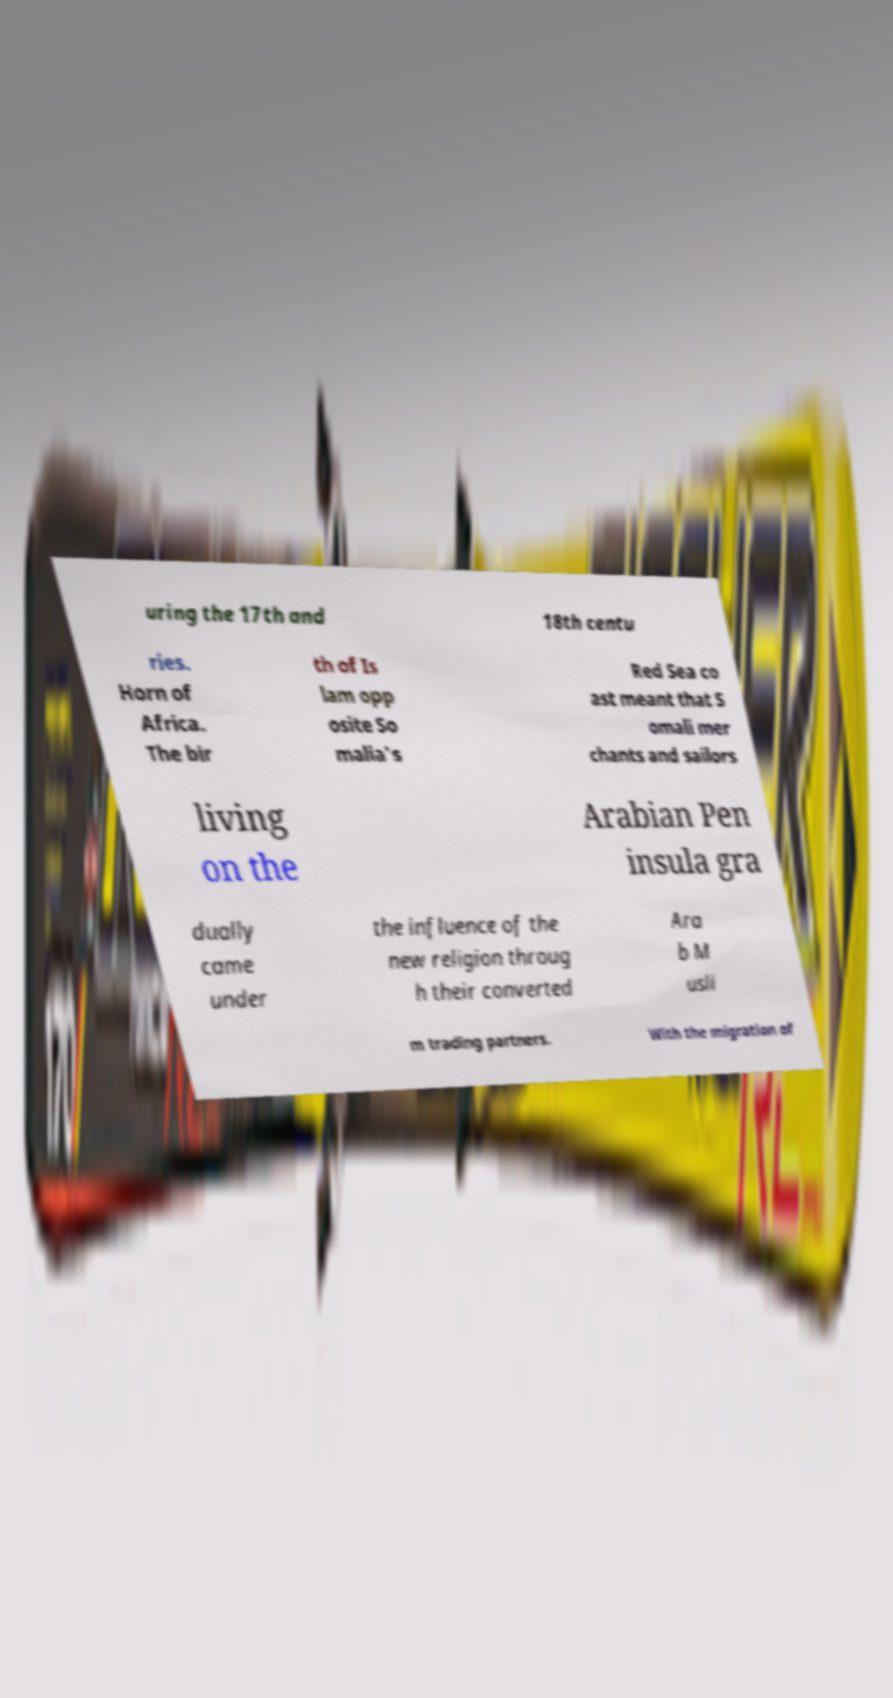Could you assist in decoding the text presented in this image and type it out clearly? uring the 17th and 18th centu ries. Horn of Africa. The bir th of Is lam opp osite So malia's Red Sea co ast meant that S omali mer chants and sailors living on the Arabian Pen insula gra dually came under the influence of the new religion throug h their converted Ara b M usli m trading partners. With the migration of 